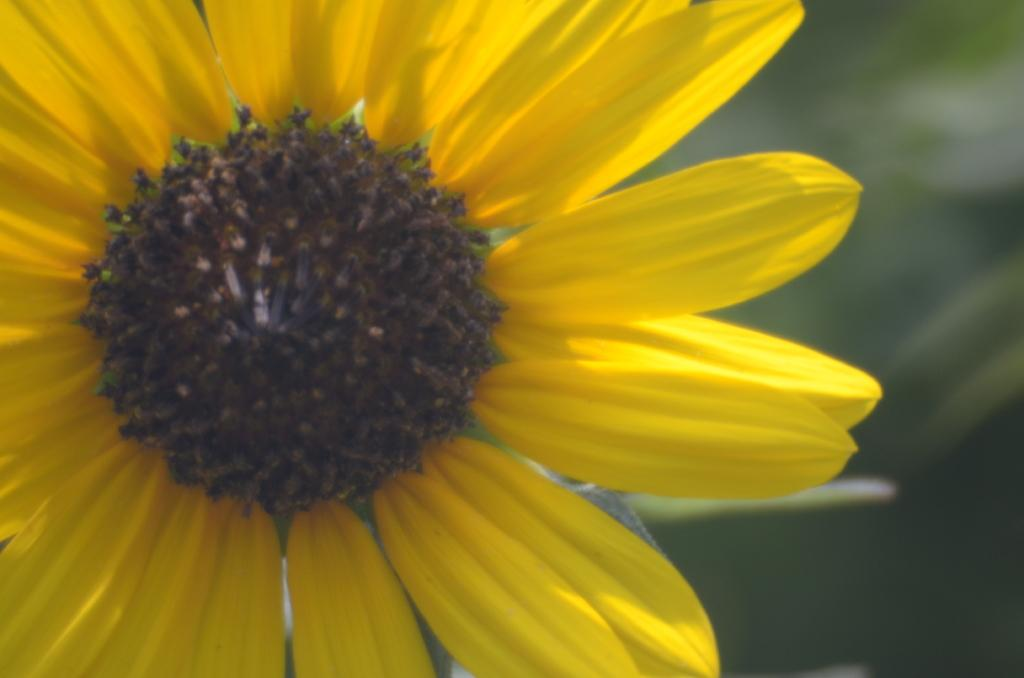What is the main subject in the front of the image? There is a flower in the front of the image. Can you describe the background of the image? The background of the image is blurry. What type of noise can be heard coming from the vegetable in the image? There is no vegetable present in the image, and therefore no noise can be heard from it. 